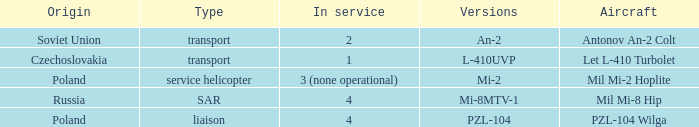Tell me the versions for czechoslovakia? L-410UVP. 